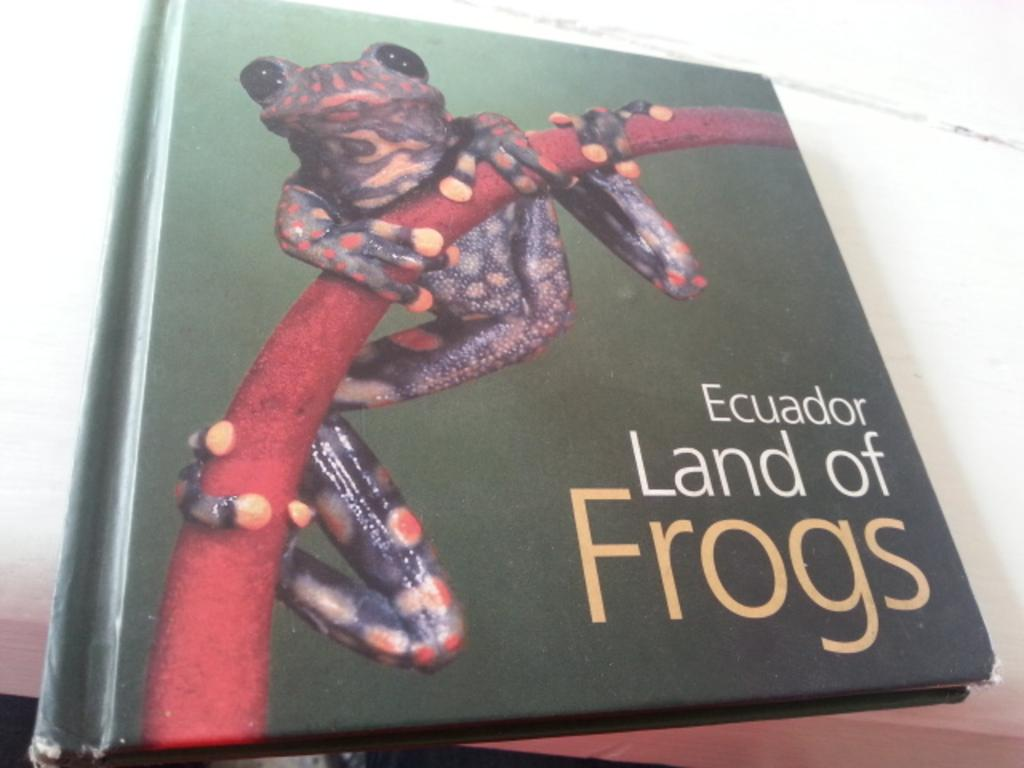<image>
Summarize the visual content of the image. The book is about the frogs in Ecuador. 